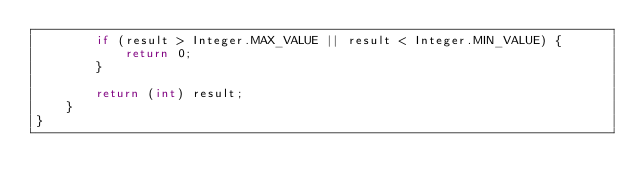<code> <loc_0><loc_0><loc_500><loc_500><_Java_>        if (result > Integer.MAX_VALUE || result < Integer.MIN_VALUE) {
            return 0;
        }

        return (int) result;
    }
}</code> 